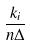<formula> <loc_0><loc_0><loc_500><loc_500>\frac { k _ { i } } { n \Delta }</formula> 